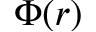<formula> <loc_0><loc_0><loc_500><loc_500>\Phi ( r )</formula> 